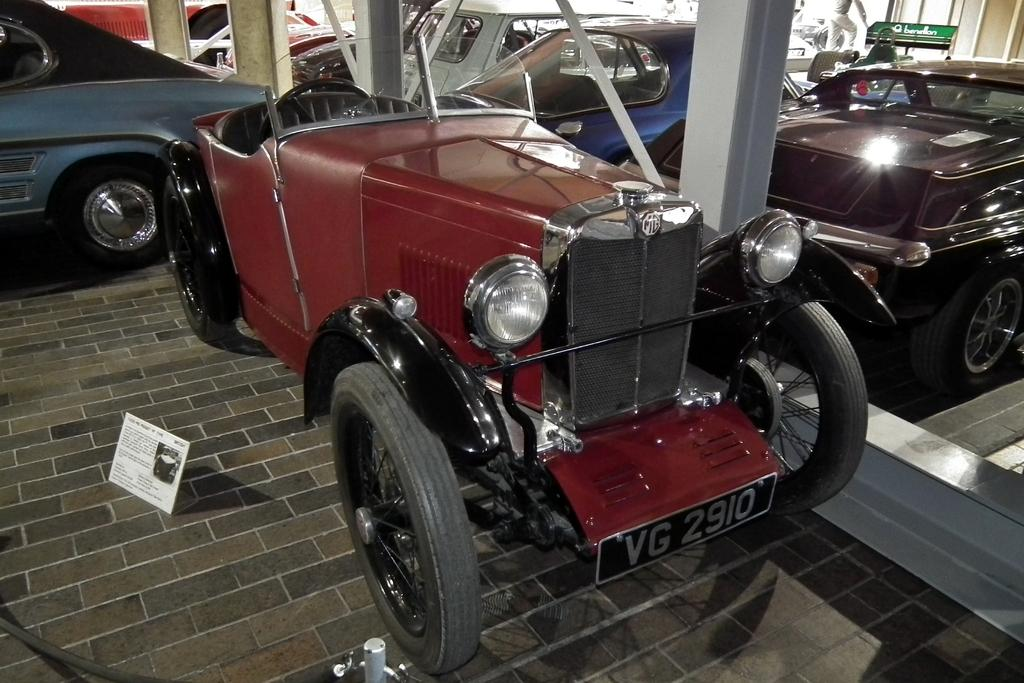<image>
Provide a brief description of the given image. An old fashion vehicle with the word VG 2910. 